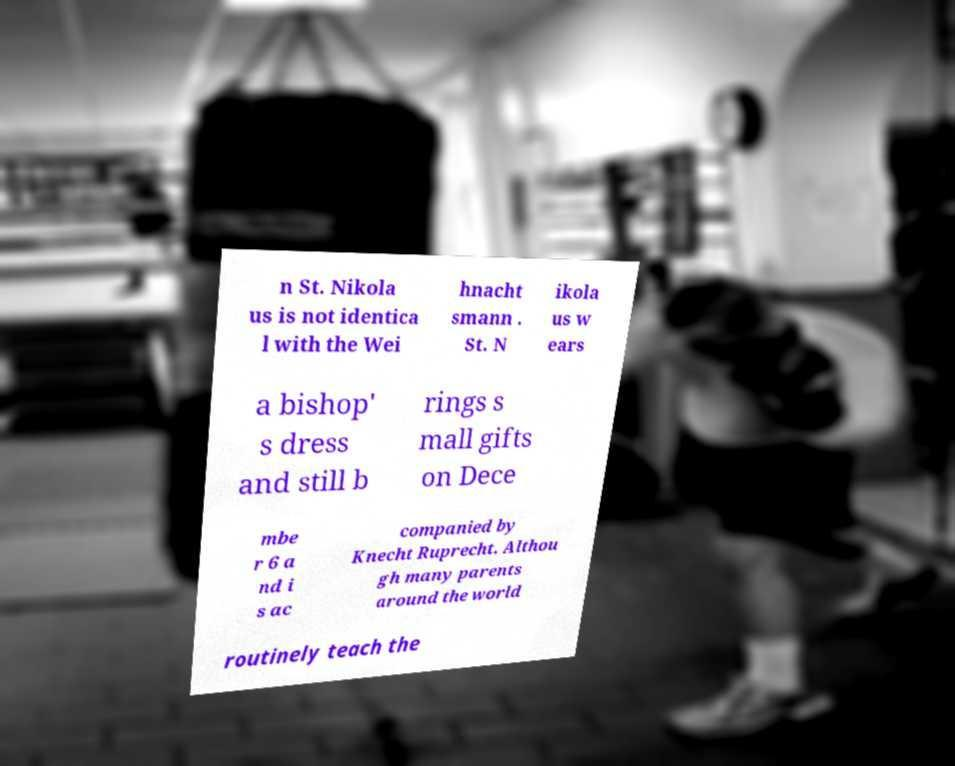I need the written content from this picture converted into text. Can you do that? n St. Nikola us is not identica l with the Wei hnacht smann . St. N ikola us w ears a bishop' s dress and still b rings s mall gifts on Dece mbe r 6 a nd i s ac companied by Knecht Ruprecht. Althou gh many parents around the world routinely teach the 